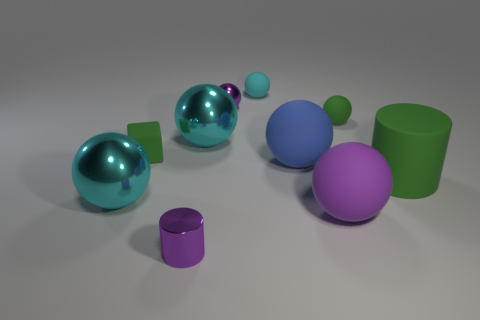There is a cylinder left of the object behind the small purple object that is behind the purple cylinder; what is it made of?
Offer a terse response. Metal. What is the shape of the large rubber object that is the same color as the tiny metallic cylinder?
Offer a very short reply. Sphere. There is a tiny thing that is the same color as the tiny cylinder; what material is it?
Keep it short and to the point. Metal. Do the large ball to the left of the tiny rubber cube and the cyan ball that is to the right of the tiny purple metal ball have the same material?
Your answer should be compact. No. What number of other things are the same color as the large cylinder?
Give a very brief answer. 2. Do the tiny metallic sphere and the small shiny cylinder have the same color?
Give a very brief answer. Yes. How many small purple cylinders are there?
Your answer should be very brief. 1. There is a small green thing on the right side of the tiny purple shiny thing that is in front of the small green rubber sphere; what is it made of?
Provide a short and direct response. Rubber. There is a green thing that is the same size as the blue sphere; what is it made of?
Keep it short and to the point. Rubber. Does the green rubber thing that is on the left side of the cyan rubber ball have the same size as the big blue matte ball?
Keep it short and to the point. No. 